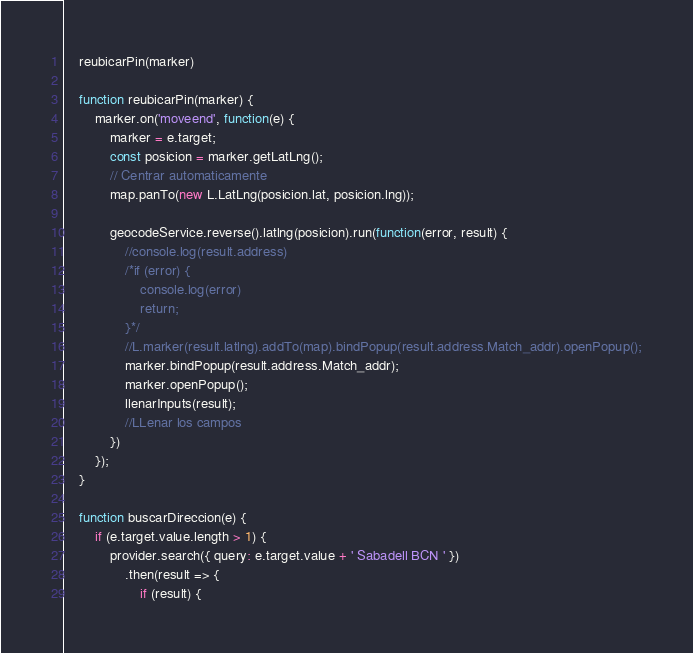<code> <loc_0><loc_0><loc_500><loc_500><_JavaScript_>
    reubicarPin(marker)

    function reubicarPin(marker) {
        marker.on('moveend', function(e) {
            marker = e.target;
            const posicion = marker.getLatLng();
            // Centrar automaticamente
            map.panTo(new L.LatLng(posicion.lat, posicion.lng));

            geocodeService.reverse().latlng(posicion).run(function(error, result) {
                //console.log(result.address)
                /*if (error) {
                    console.log(error)
                    return;
                }*/
                //L.marker(result.latlng).addTo(map).bindPopup(result.address.Match_addr).openPopup();
                marker.bindPopup(result.address.Match_addr);
                marker.openPopup();
                llenarInputs(result);
                //LLenar los campos
            })
        });
    }

    function buscarDireccion(e) {
        if (e.target.value.length > 1) {
            provider.search({ query: e.target.value + ' Sabadell BCN ' })
                .then(result => {
                    if (result) {
</code> 